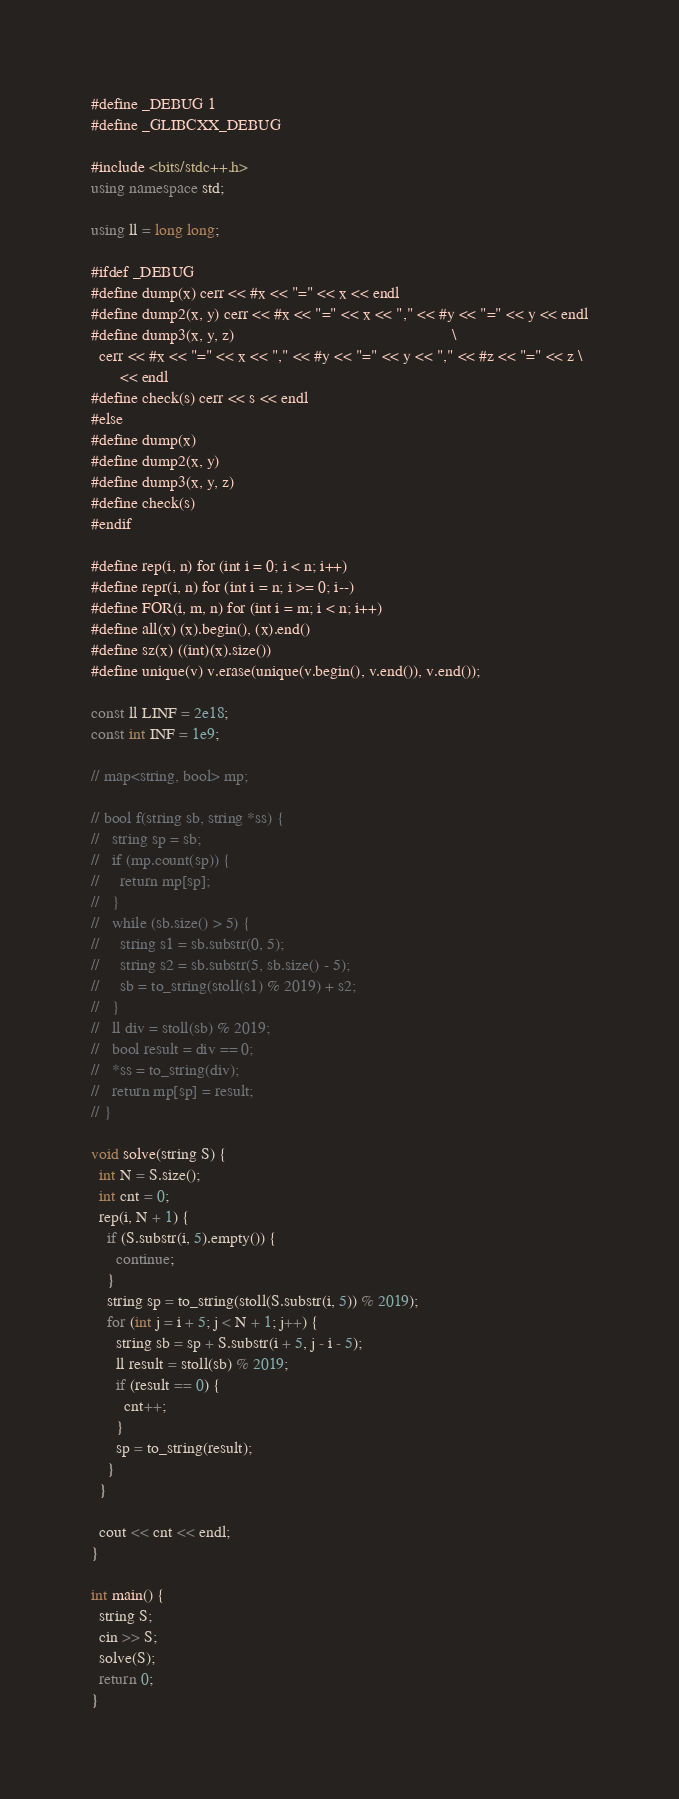<code> <loc_0><loc_0><loc_500><loc_500><_C++_>#define _DEBUG 1
#define _GLIBCXX_DEBUG

#include <bits/stdc++.h>
using namespace std;

using ll = long long;

#ifdef _DEBUG
#define dump(x) cerr << #x << "=" << x << endl
#define dump2(x, y) cerr << #x << "=" << x << "," << #y << "=" << y << endl
#define dump3(x, y, z)                                                     \
  cerr << #x << "=" << x << "," << #y << "=" << y << "," << #z << "=" << z \
       << endl
#define check(s) cerr << s << endl
#else
#define dump(x)
#define dump2(x, y)
#define dump3(x, y, z)
#define check(s)
#endif

#define rep(i, n) for (int i = 0; i < n; i++)
#define repr(i, n) for (int i = n; i >= 0; i--)
#define FOR(i, m, n) for (int i = m; i < n; i++)
#define all(x) (x).begin(), (x).end()
#define sz(x) ((int)(x).size())
#define unique(v) v.erase(unique(v.begin(), v.end()), v.end());

const ll LINF = 2e18;
const int INF = 1e9;

// map<string, bool> mp;

// bool f(string sb, string *ss) {
//   string sp = sb;
//   if (mp.count(sp)) {
//     return mp[sp];
//   }
//   while (sb.size() > 5) {
//     string s1 = sb.substr(0, 5);
//     string s2 = sb.substr(5, sb.size() - 5);
//     sb = to_string(stoll(s1) % 2019) + s2;
//   }
//   ll div = stoll(sb) % 2019;
//   bool result = div == 0;
//   *ss = to_string(div);
//   return mp[sp] = result;
// }

void solve(string S) {
  int N = S.size();
  int cnt = 0;
  rep(i, N + 1) {
    if (S.substr(i, 5).empty()) {
      continue;
    }
    string sp = to_string(stoll(S.substr(i, 5)) % 2019);
    for (int j = i + 5; j < N + 1; j++) {
      string sb = sp + S.substr(i + 5, j - i - 5);
      ll result = stoll(sb) % 2019;
      if (result == 0) {
        cnt++;
      }
      sp = to_string(result);
    }
  }

  cout << cnt << endl;
}

int main() {
  string S;
  cin >> S;
  solve(S);
  return 0;
}
</code> 